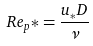<formula> <loc_0><loc_0><loc_500><loc_500>R e _ { p } * = \frac { u _ { * } D } { \nu }</formula> 